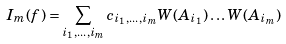Convert formula to latex. <formula><loc_0><loc_0><loc_500><loc_500>I _ { m } ( f ) = \sum _ { i _ { 1 } , \dots , i _ { m } } c _ { i _ { 1 } , \dots , i _ { m } } W ( A _ { i _ { 1 } } ) \dots W ( A _ { i _ { m } } )</formula> 